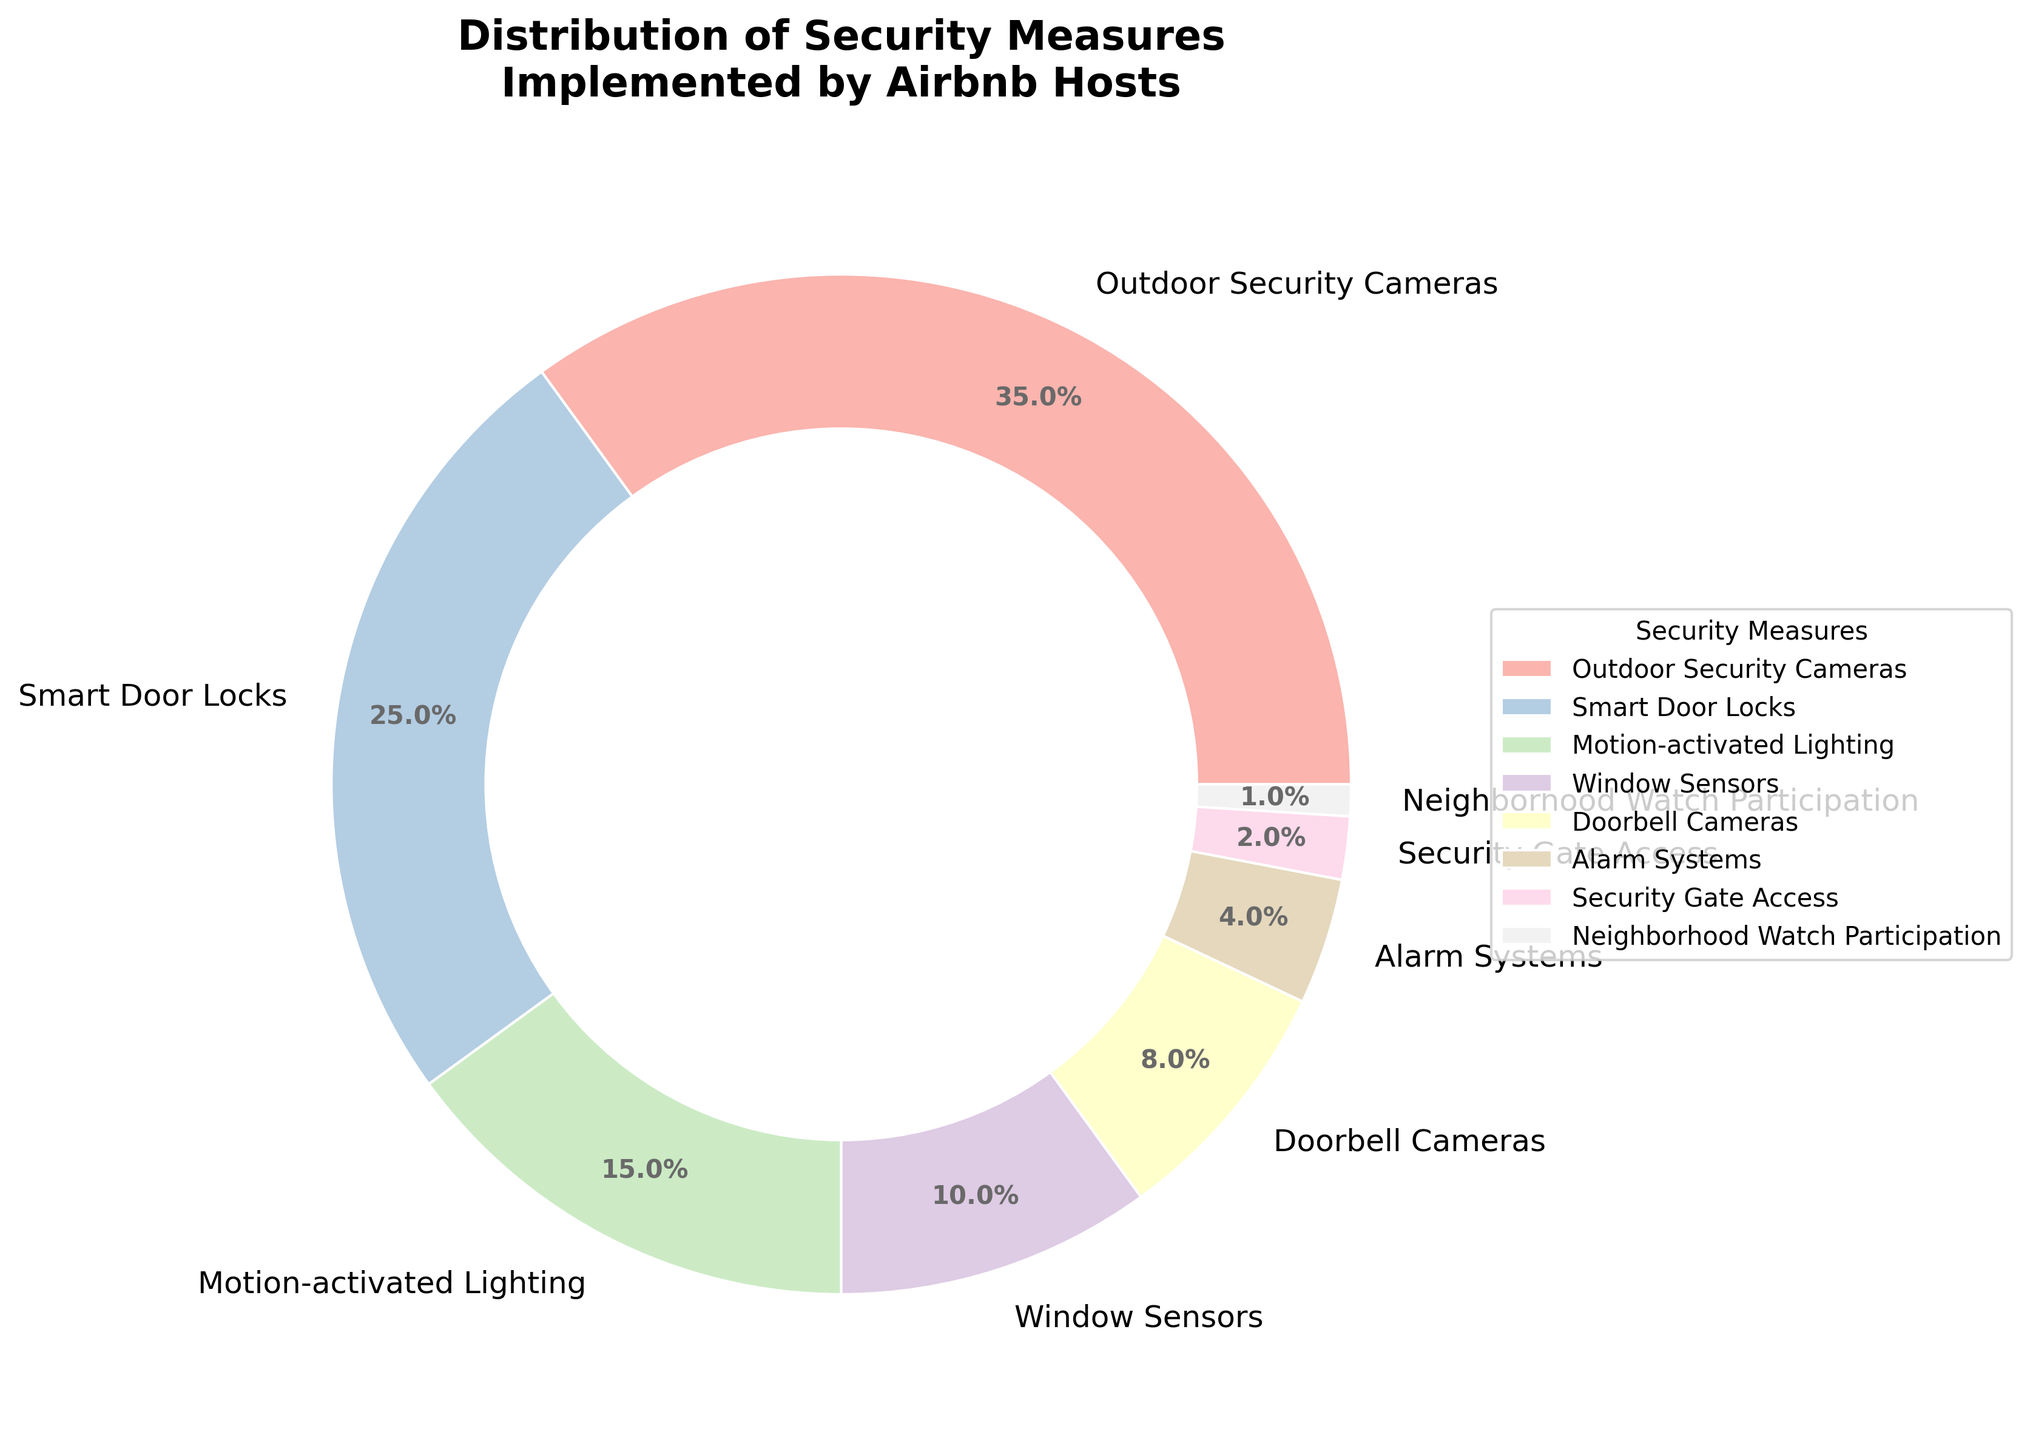Which security measure is implemented the most by Airbnb hosts? The pie chart shows the percentage distribution of different security measures. The section with the highest percentage is the most implemented. 'Outdoor Security Cameras' has the highest percentage at 35%.
Answer: Outdoor Security Cameras Which two security measures have the closest percentage of implementation? By looking at the percentage values, 'Motion-activated Lighting' at 15% and 'Window Sensors' at 10% are closest in percentage.
Answer: Motion-activated Lighting and Window Sensors What is the total percentage of security measures that involve cameras (Outdoor Security Cameras and Doorbell Cameras)? Adding the percentages of 'Outdoor Security Cameras' (35%) and 'Doorbell Cameras' (8%) gives 35 + 8 = 43%.
Answer: 43% How does the percentage of 'Smart Door Locks' compare to 'Alarm Systems'? Comparing the two percentages, 'Smart Door Locks' is at 25% and 'Alarm Systems' is at 4%. 'Smart Door Locks' is 21 percentage points higher.
Answer: 21 percentage points higher What proportion of the security measures account for more than 10% each? Identifying the security measures with more than 10%: 'Outdoor Security Cameras' (35%), 'Smart Door Locks' (25%), and 'Motion-activated Lighting' (15%). These are 3 out of the 8 measures.
Answer: 3 out of 8 What is the combined percentage of the three least implemented security measures? Adding the percentages of 'Security Gate Access' (2%), 'Neighborhood Watch Participation' (1%), and 'Alarm Systems' (4%) results in a total of 2 + 1 + 4 = 7%.
Answer: 7% Is the percentage of 'Motion-activated Lighting' greater than the sum of 'Doorbell Cameras' and 'Window Sensors'? Adding 'Doorbell Cameras' (8%) and 'Window Sensors' (10%) gives 8 + 10 = 18%. 'Motion-activated Lighting' is at 15%, which is less than 18%.
Answer: No What is the difference in percentage between the most and least implemented security measures? The 'Outdoor Security Cameras' measure is the most implemented at 35%, and 'Neighborhood Watch Participation' is the least at 1%. The difference is 35 - 1 = 34%.
Answer: 34% Do more security measures have implementation percentages above or below 10%? There are 4 measures above 10%: 'Outdoor Security Cameras' (35%), 'Smart Door Locks' (25%), 'Motion-activated Lighting' (15%), and 'Window Sensors' (10%). There are 4 measures below 10%: 'Doorbell Cameras' (8%), 'Alarm Systems' (4%), 'Security Gate Access' (2%), and 'Neighborhood Watch Participation' (1%). Both categories have equal counts.
Answer: Equal Which security measures together constitute more than half of the total implementation? The sum of 'Outdoor Security Cameras' (35%) and 'Smart Door Locks' (25%) is 35 + 25 = 60%, which is more than half.
Answer: Outdoor Security Cameras and Smart Door Locks 